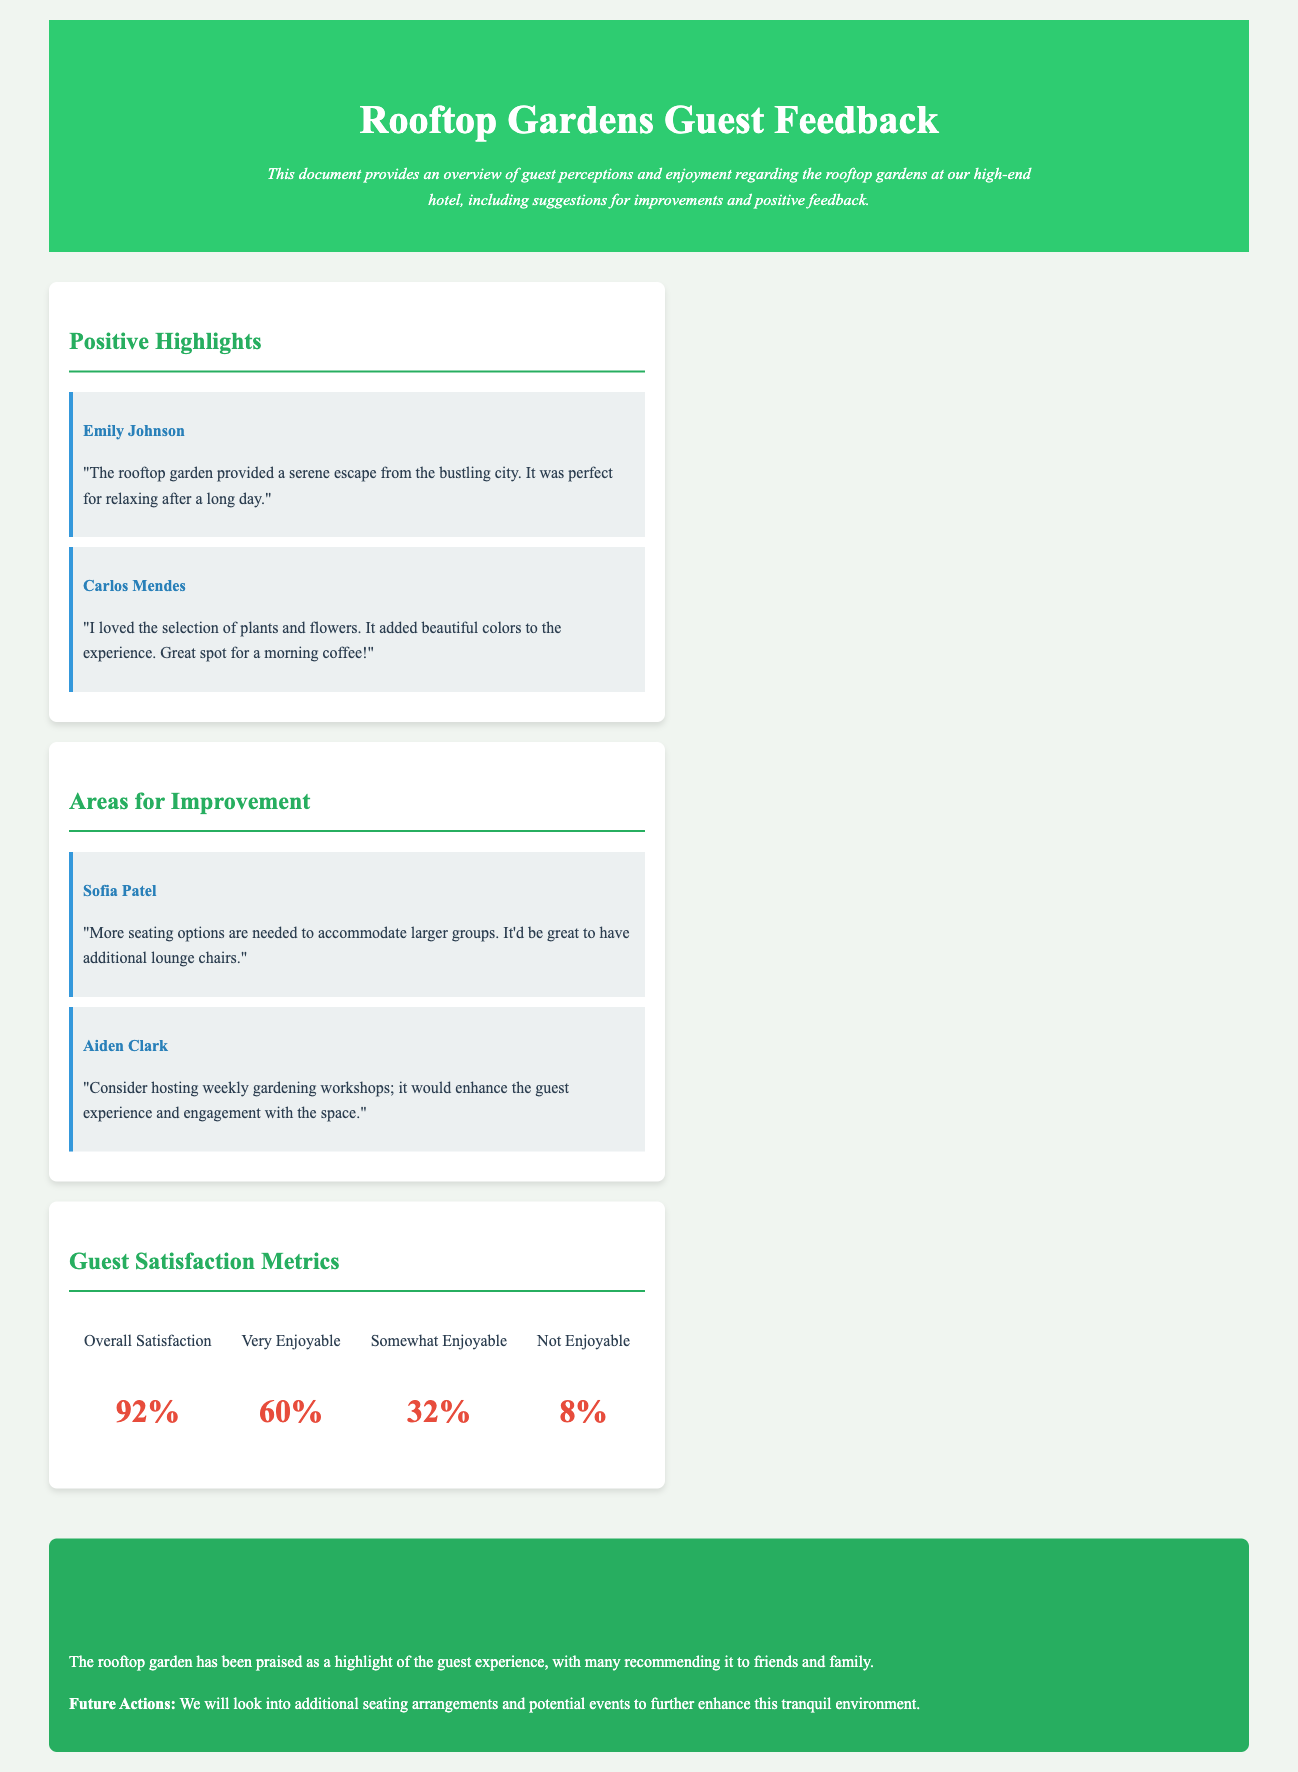What is the overall satisfaction percentage? The overall satisfaction percentage is stated in the guest satisfaction metrics section of the document.
Answer: 92% Who mentioned the serene escape provided by the rooftop garden? Emily Johnson is the guest who praised the rooftop garden for its serene escape.
Answer: Emily Johnson What suggestion did Sofia Patel provide for improvement? Sofia Patel suggested more seating options in her feedback.
Answer: More seating options What percentage of guests found the rooftop garden very enjoyable? The percentage of guests who found the rooftop garden very enjoyable is indicated in the metrics section.
Answer: 60% What type of events did Aiden Clark suggest for enhancing guest experience? Aiden Clark suggested hosting weekly gardening workshops to enhance guest engagement.
Answer: Weekly gardening workshops How many guests found the rooftop garden not enjoyable? This percentage is specified in the guest satisfaction metrics section.
Answer: 8% 